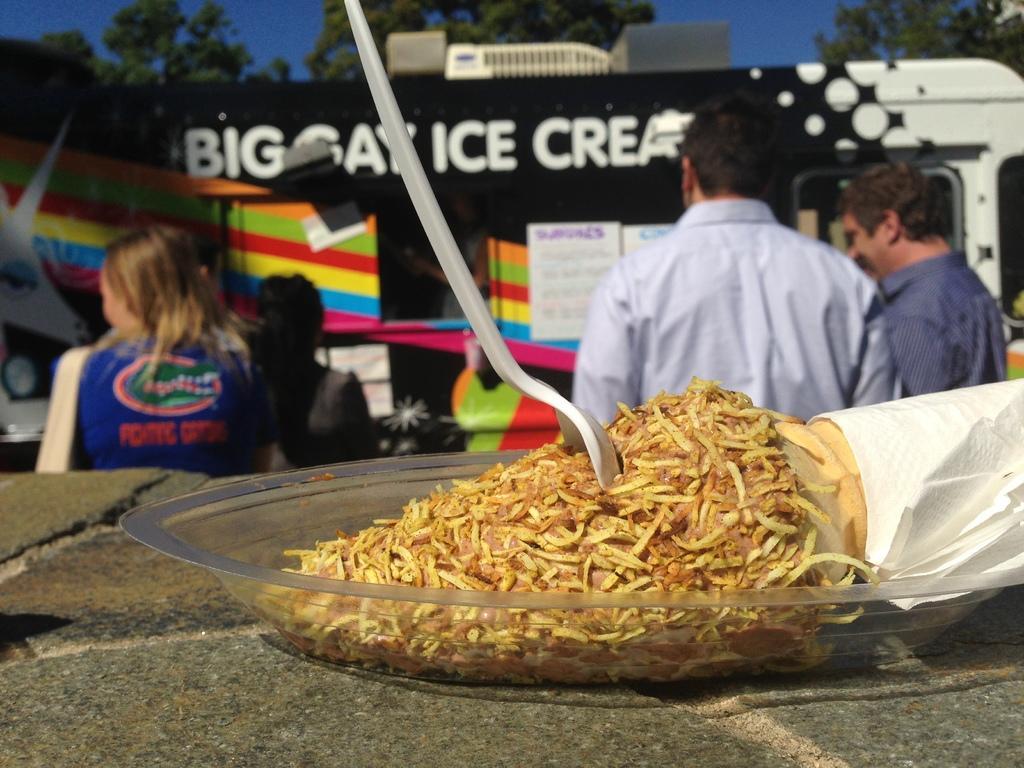Please provide a concise description of this image. This image consists of a food item kept in a plate along with a spoon. In the background, there are few persons. And we can see a vehicle. It looks like a food cart. At the top, there are trees along with sky. 